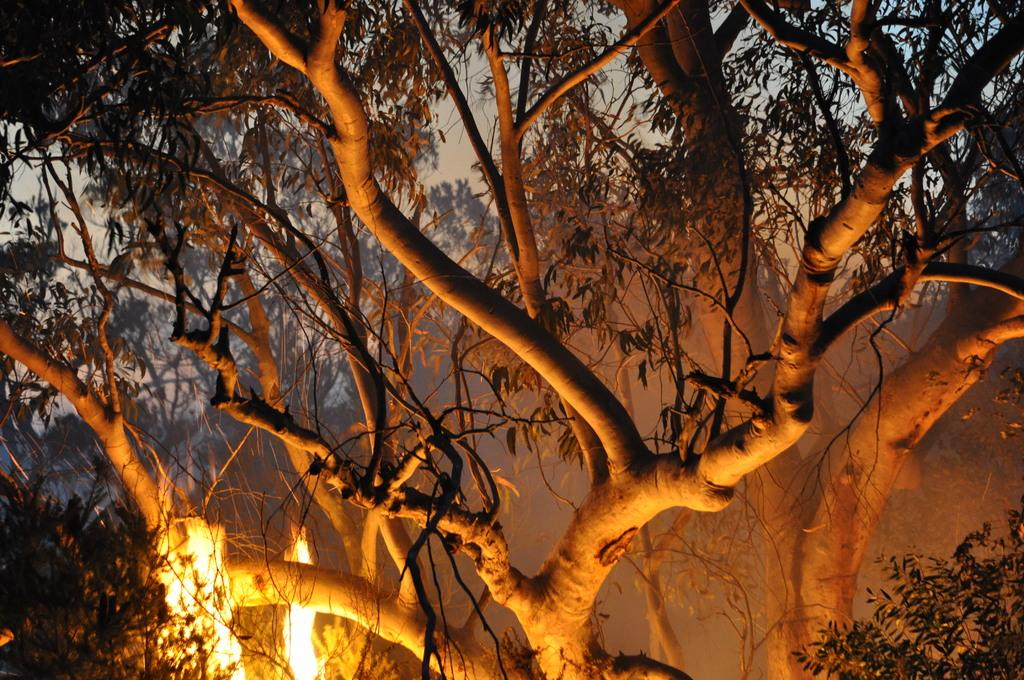What type of vegetation can be seen in the image? There are trees in the image. What part of the natural environment is visible in the image? The sky is visible in the background of the image. What type of quartz can be seen in the image? There is no quartz present in the image; it features trees and the sky. How many steps are visible in the image? There are no steps visible in the image. 